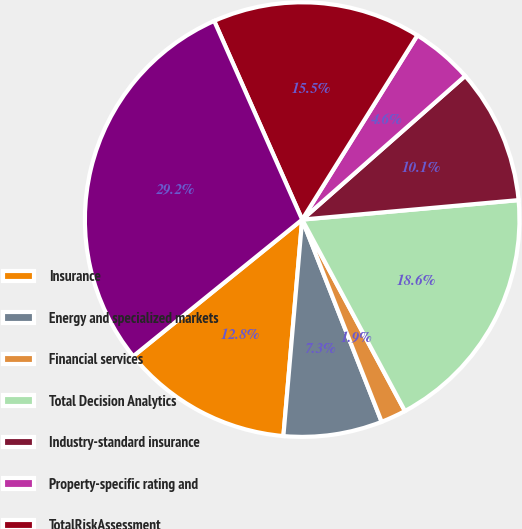Convert chart. <chart><loc_0><loc_0><loc_500><loc_500><pie_chart><fcel>Insurance<fcel>Energy and specialized markets<fcel>Financial services<fcel>Total Decision Analytics<fcel>Industry-standard insurance<fcel>Property-specific rating and<fcel>TotalRiskAssessment<fcel>Total consolidated revenues<nl><fcel>12.8%<fcel>7.34%<fcel>1.88%<fcel>18.59%<fcel>10.07%<fcel>4.61%<fcel>15.53%<fcel>29.19%<nl></chart> 